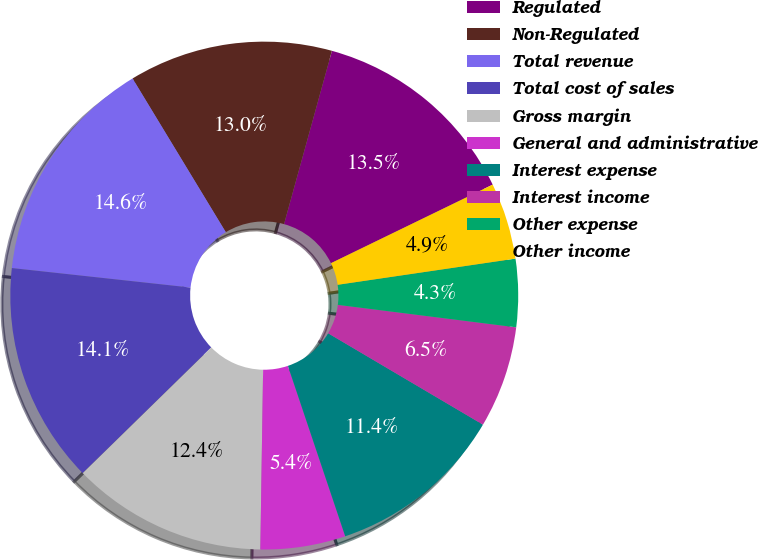Convert chart to OTSL. <chart><loc_0><loc_0><loc_500><loc_500><pie_chart><fcel>Regulated<fcel>Non-Regulated<fcel>Total revenue<fcel>Total cost of sales<fcel>Gross margin<fcel>General and administrative<fcel>Interest expense<fcel>Interest income<fcel>Other expense<fcel>Other income<nl><fcel>13.51%<fcel>12.97%<fcel>14.59%<fcel>14.05%<fcel>12.43%<fcel>5.41%<fcel>11.35%<fcel>6.49%<fcel>4.32%<fcel>4.87%<nl></chart> 